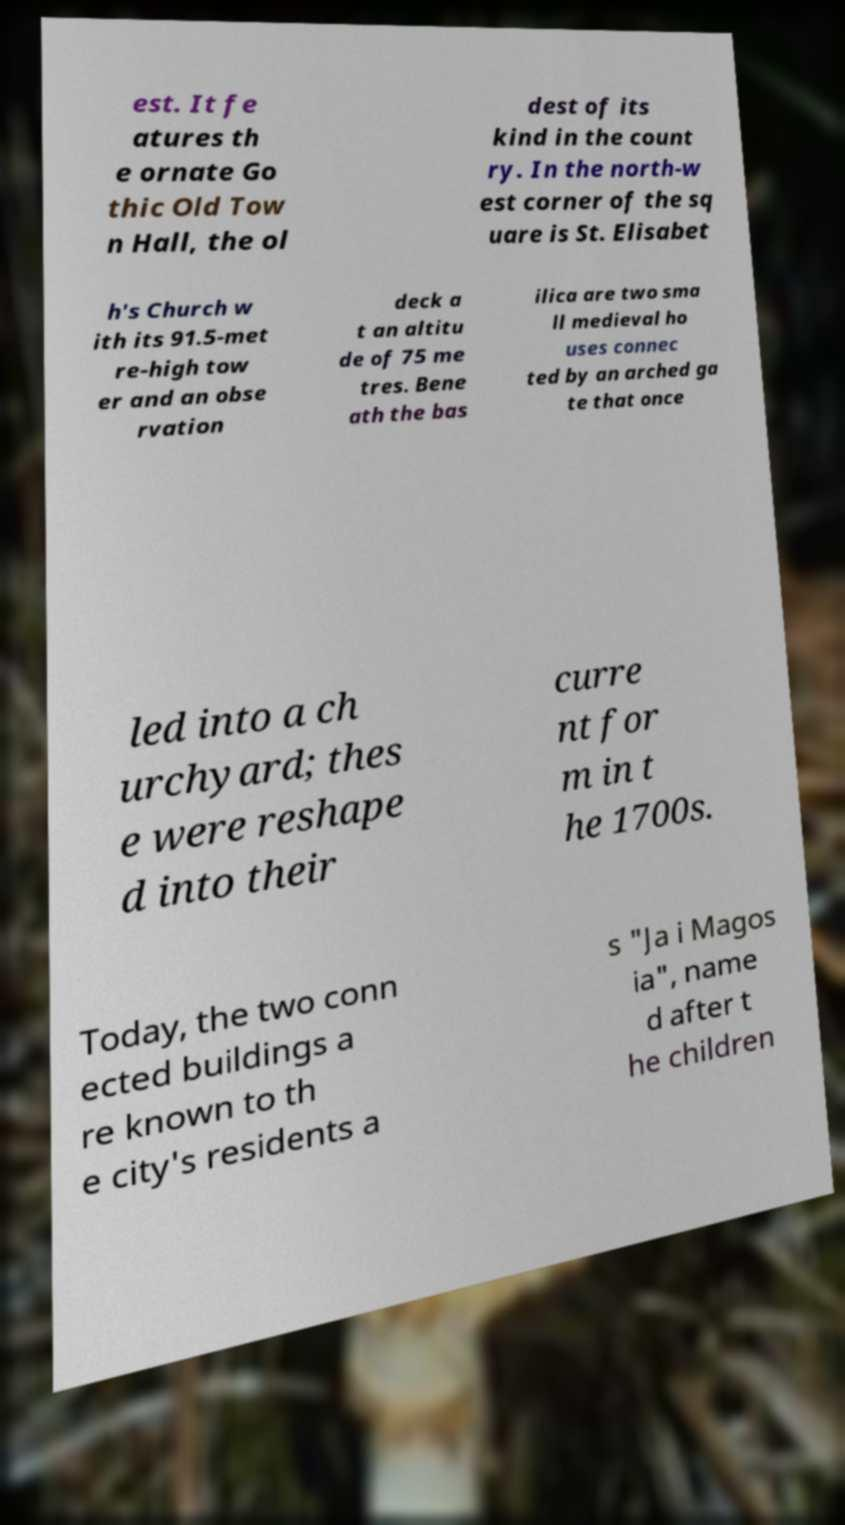There's text embedded in this image that I need extracted. Can you transcribe it verbatim? est. It fe atures th e ornate Go thic Old Tow n Hall, the ol dest of its kind in the count ry. In the north-w est corner of the sq uare is St. Elisabet h's Church w ith its 91.5-met re-high tow er and an obse rvation deck a t an altitu de of 75 me tres. Bene ath the bas ilica are two sma ll medieval ho uses connec ted by an arched ga te that once led into a ch urchyard; thes e were reshape d into their curre nt for m in t he 1700s. Today, the two conn ected buildings a re known to th e city's residents a s "Ja i Magos ia", name d after t he children 